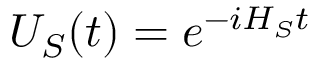Convert formula to latex. <formula><loc_0><loc_0><loc_500><loc_500>U _ { S } ( t ) = e ^ { - i H _ { S } t }</formula> 